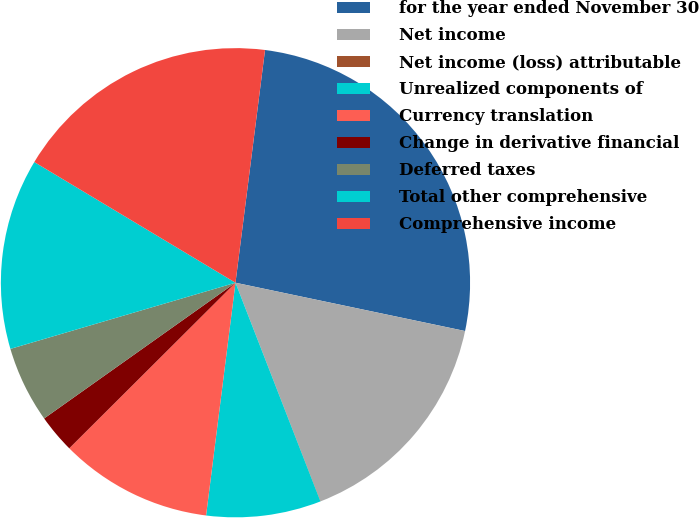Convert chart. <chart><loc_0><loc_0><loc_500><loc_500><pie_chart><fcel>for the year ended November 30<fcel>Net income<fcel>Net income (loss) attributable<fcel>Unrealized components of<fcel>Currency translation<fcel>Change in derivative financial<fcel>Deferred taxes<fcel>Total other comprehensive<fcel>Comprehensive income<nl><fcel>26.29%<fcel>15.78%<fcel>0.02%<fcel>7.9%<fcel>10.53%<fcel>2.65%<fcel>5.27%<fcel>13.15%<fcel>18.41%<nl></chart> 